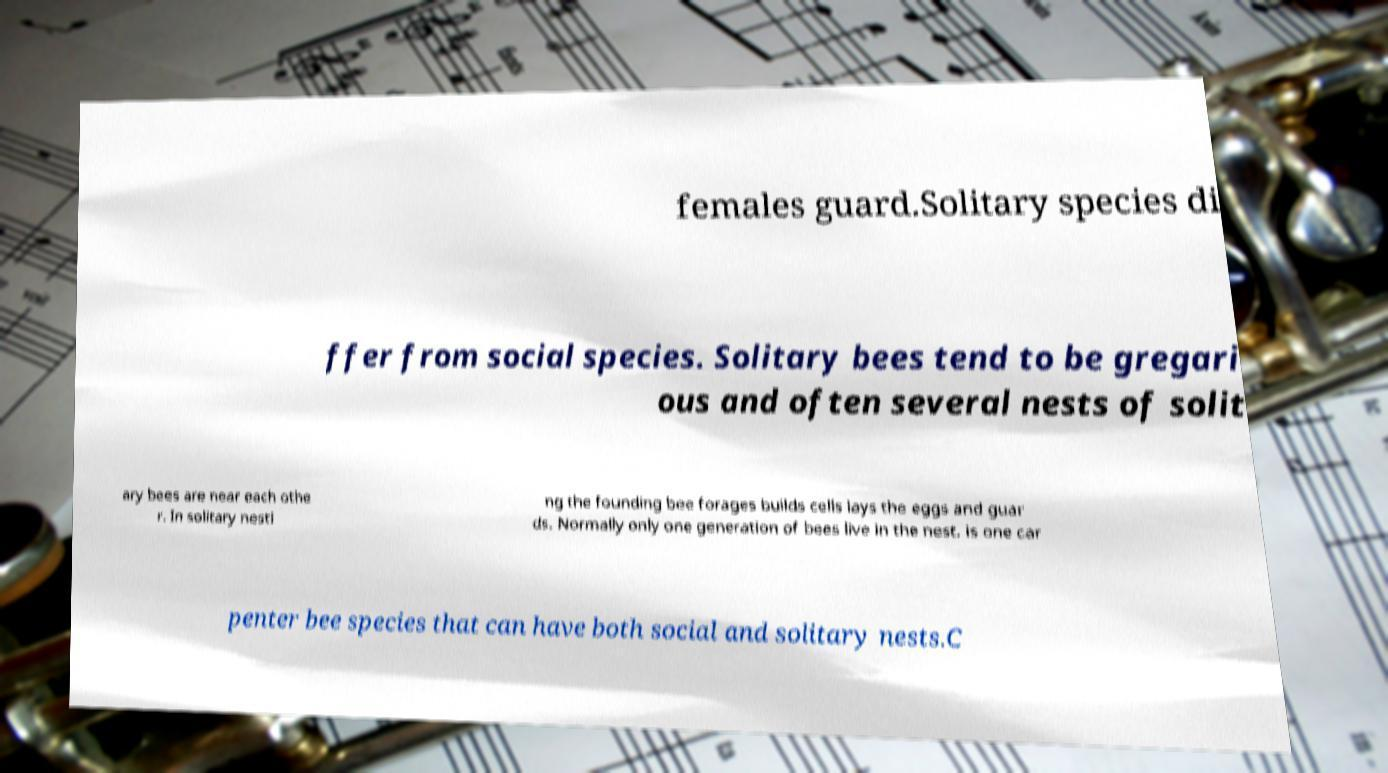I need the written content from this picture converted into text. Can you do that? females guard.Solitary species di ffer from social species. Solitary bees tend to be gregari ous and often several nests of solit ary bees are near each othe r. In solitary nesti ng the founding bee forages builds cells lays the eggs and guar ds. Normally only one generation of bees live in the nest. is one car penter bee species that can have both social and solitary nests.C 